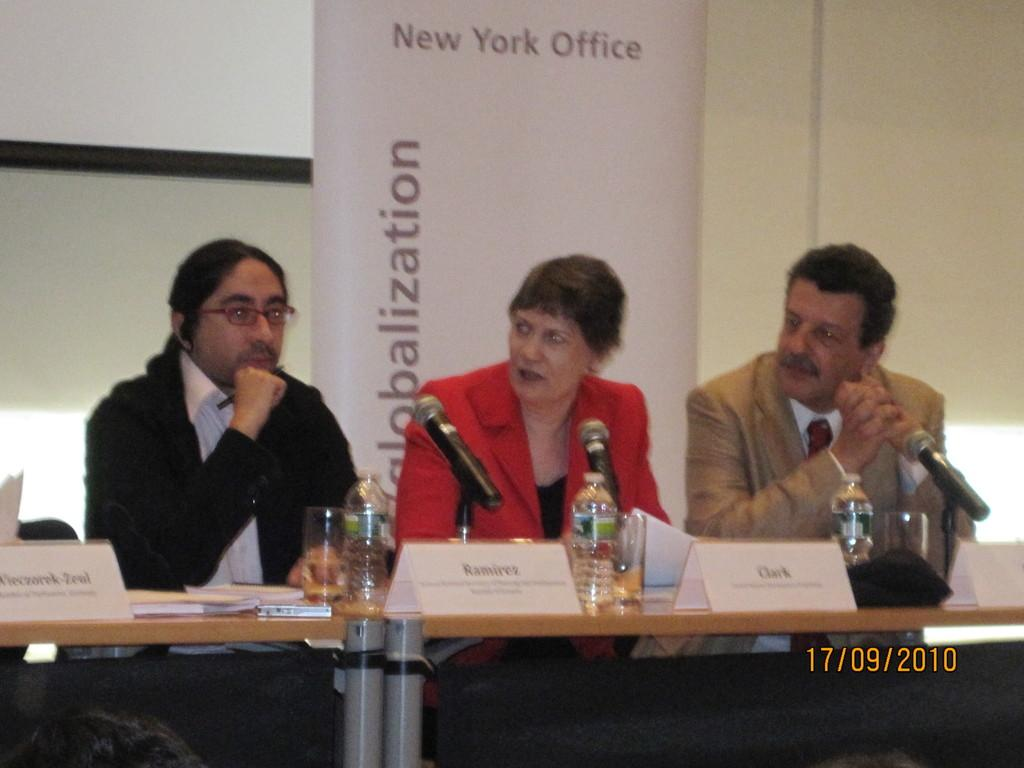What is the main subject in the middle of the image? There is a woman sitting in the middle of the image. What is the woman wearing? The woman is wearing a red dress. Who is sitting on either side of the woman? There are two men sitting on either side of the woman. What can be seen on the table in the image? There are water bottles on the table. What type of vessel is the woman using to sail in the image? There is no vessel present in the image, and the woman is not sailing. 